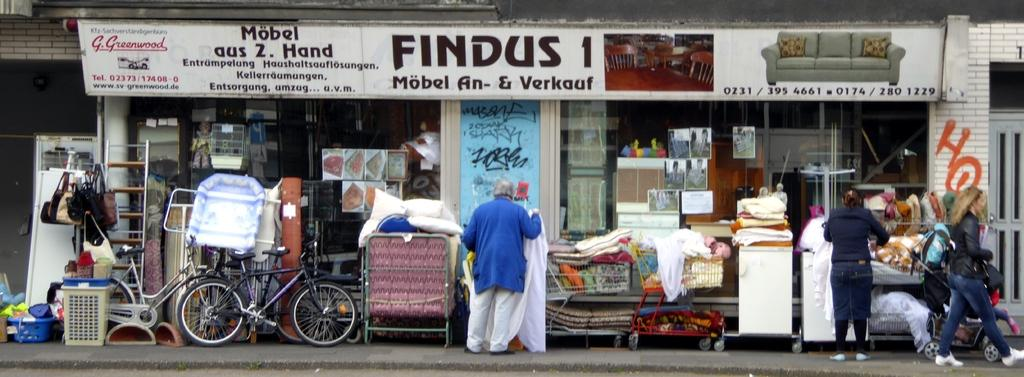Provide a one-sentence caption for the provided image. A white sign says "FINDUS" above a shop. 